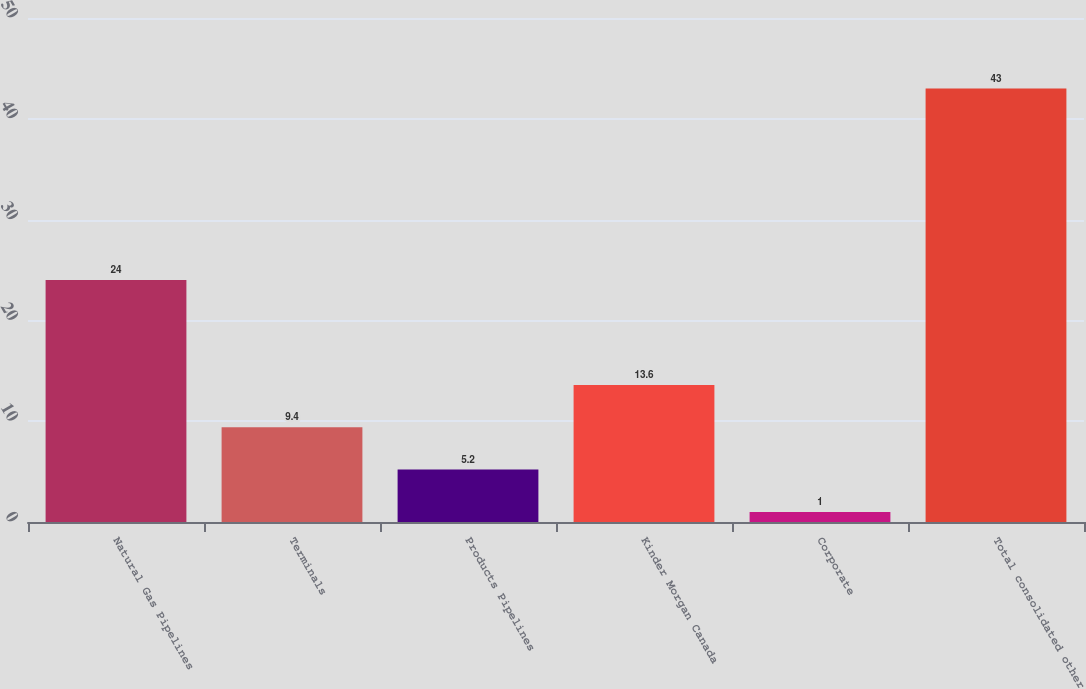<chart> <loc_0><loc_0><loc_500><loc_500><bar_chart><fcel>Natural Gas Pipelines<fcel>Terminals<fcel>Products Pipelines<fcel>Kinder Morgan Canada<fcel>Corporate<fcel>Total consolidated other<nl><fcel>24<fcel>9.4<fcel>5.2<fcel>13.6<fcel>1<fcel>43<nl></chart> 